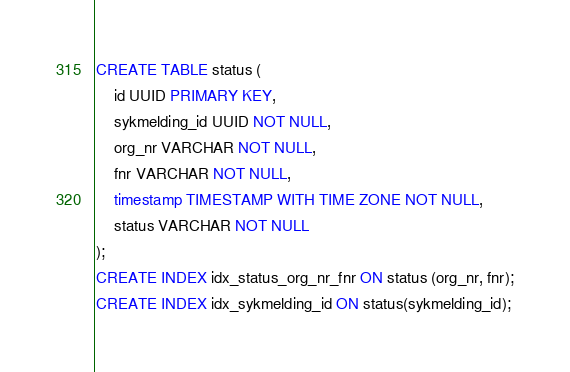<code> <loc_0><loc_0><loc_500><loc_500><_SQL_>CREATE TABLE status (
    id UUID PRIMARY KEY,
    sykmelding_id UUID NOT NULL,
    org_nr VARCHAR NOT NULL,
    fnr VARCHAR NOT NULL,
    timestamp TIMESTAMP WITH TIME ZONE NOT NULL,
    status VARCHAR NOT NULL
);
CREATE INDEX idx_status_org_nr_fnr ON status (org_nr, fnr);
CREATE INDEX idx_sykmelding_id ON status(sykmelding_id);</code> 